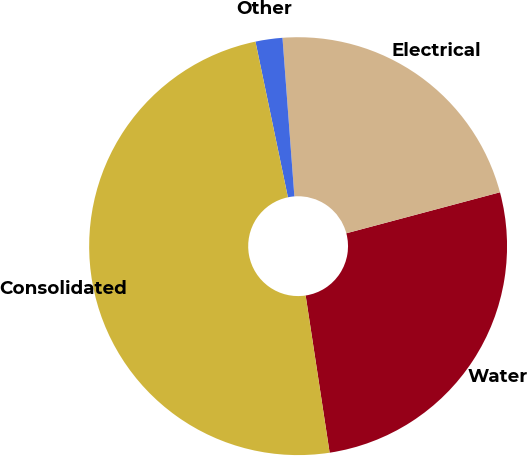<chart> <loc_0><loc_0><loc_500><loc_500><pie_chart><fcel>Water<fcel>Electrical<fcel>Other<fcel>Consolidated<nl><fcel>26.74%<fcel>22.04%<fcel>2.08%<fcel>49.14%<nl></chart> 